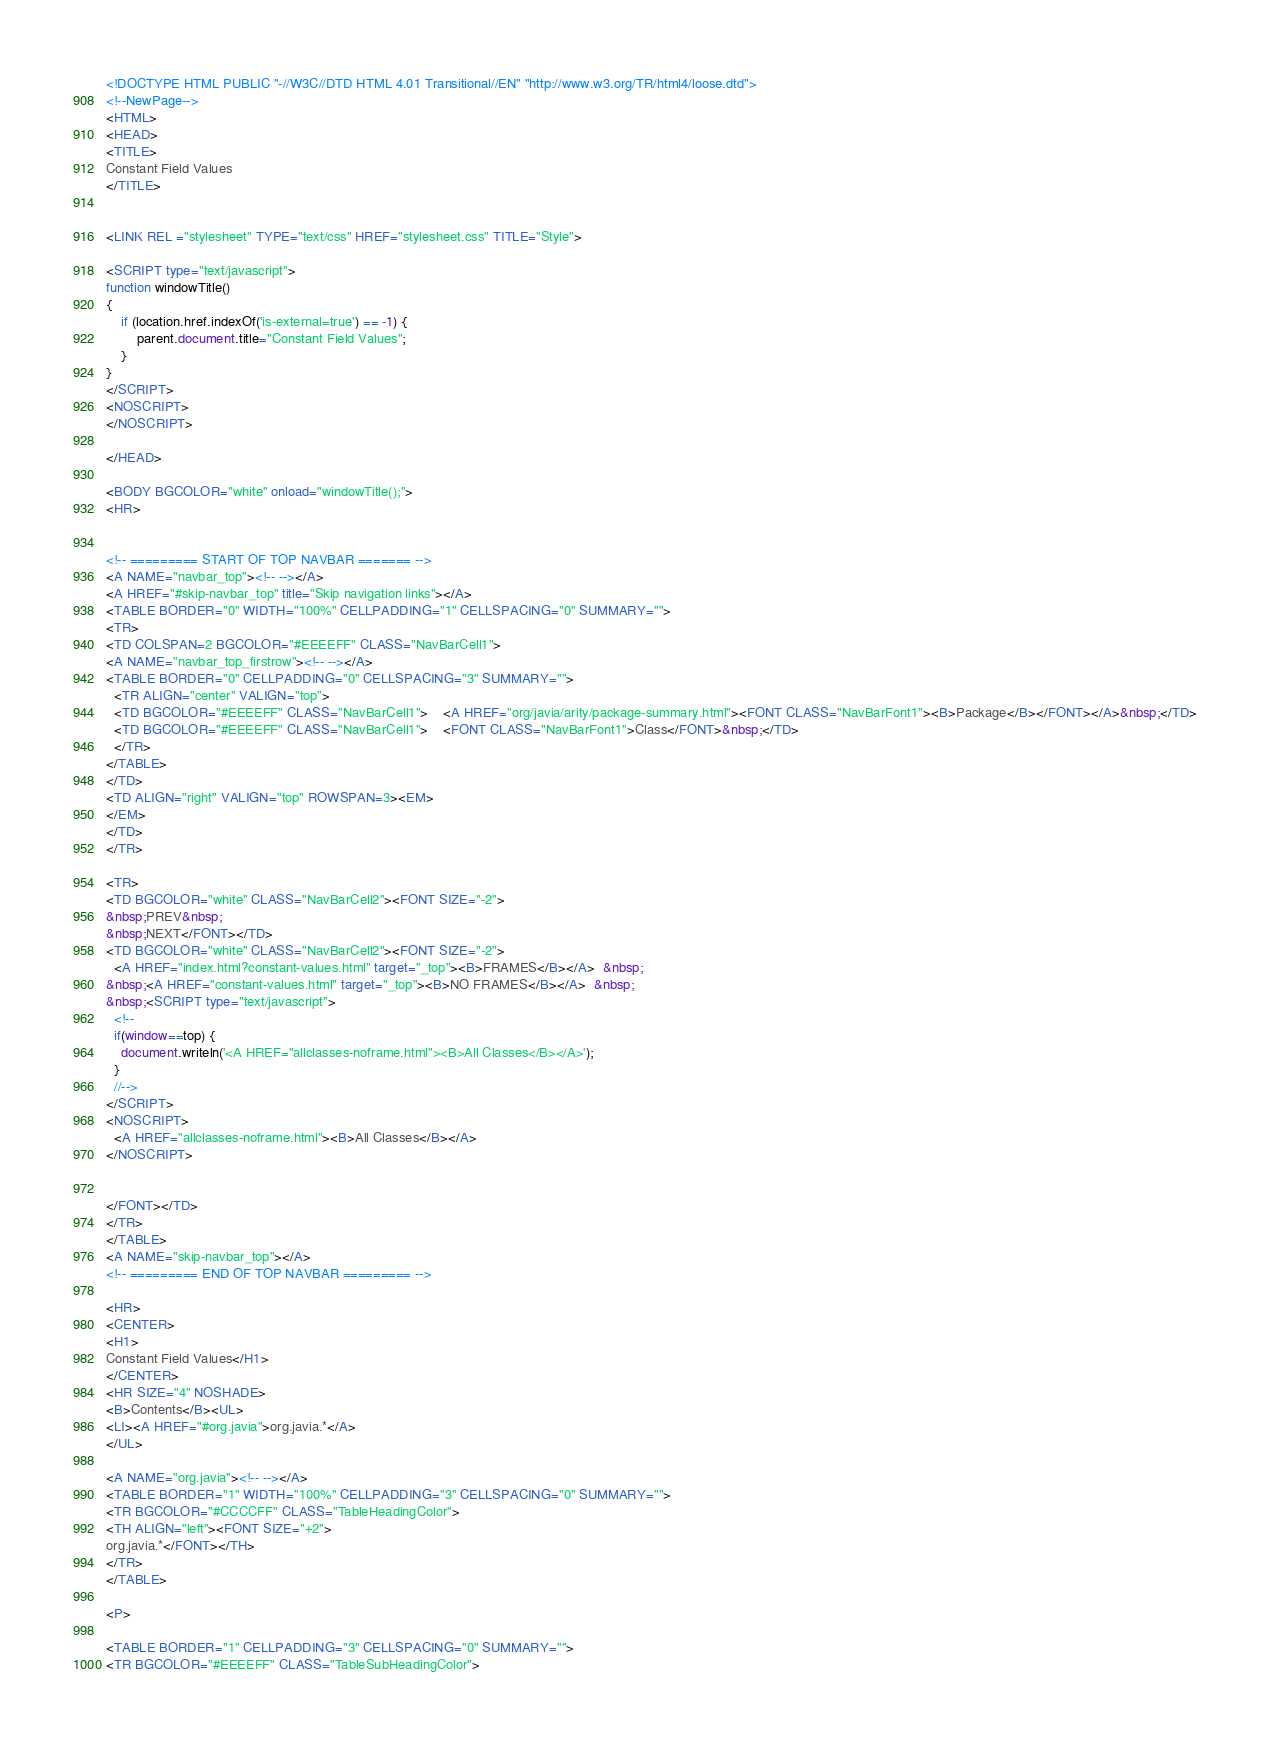Convert code to text. <code><loc_0><loc_0><loc_500><loc_500><_HTML_><!DOCTYPE HTML PUBLIC "-//W3C//DTD HTML 4.01 Transitional//EN" "http://www.w3.org/TR/html4/loose.dtd">
<!--NewPage-->
<HTML>
<HEAD>
<TITLE>
Constant Field Values
</TITLE>


<LINK REL ="stylesheet" TYPE="text/css" HREF="stylesheet.css" TITLE="Style">

<SCRIPT type="text/javascript">
function windowTitle()
{
    if (location.href.indexOf('is-external=true') == -1) {
        parent.document.title="Constant Field Values";
    }
}
</SCRIPT>
<NOSCRIPT>
</NOSCRIPT>

</HEAD>

<BODY BGCOLOR="white" onload="windowTitle();">
<HR>


<!-- ========= START OF TOP NAVBAR ======= -->
<A NAME="navbar_top"><!-- --></A>
<A HREF="#skip-navbar_top" title="Skip navigation links"></A>
<TABLE BORDER="0" WIDTH="100%" CELLPADDING="1" CELLSPACING="0" SUMMARY="">
<TR>
<TD COLSPAN=2 BGCOLOR="#EEEEFF" CLASS="NavBarCell1">
<A NAME="navbar_top_firstrow"><!-- --></A>
<TABLE BORDER="0" CELLPADDING="0" CELLSPACING="3" SUMMARY="">
  <TR ALIGN="center" VALIGN="top">
  <TD BGCOLOR="#EEEEFF" CLASS="NavBarCell1">    <A HREF="org/javia/arity/package-summary.html"><FONT CLASS="NavBarFont1"><B>Package</B></FONT></A>&nbsp;</TD>
  <TD BGCOLOR="#EEEEFF" CLASS="NavBarCell1">    <FONT CLASS="NavBarFont1">Class</FONT>&nbsp;</TD>
  </TR>
</TABLE>
</TD>
<TD ALIGN="right" VALIGN="top" ROWSPAN=3><EM>
</EM>
</TD>
</TR>

<TR>
<TD BGCOLOR="white" CLASS="NavBarCell2"><FONT SIZE="-2">
&nbsp;PREV&nbsp;
&nbsp;NEXT</FONT></TD>
<TD BGCOLOR="white" CLASS="NavBarCell2"><FONT SIZE="-2">
  <A HREF="index.html?constant-values.html" target="_top"><B>FRAMES</B></A>  &nbsp;
&nbsp;<A HREF="constant-values.html" target="_top"><B>NO FRAMES</B></A>  &nbsp;
&nbsp;<SCRIPT type="text/javascript">
  <!--
  if(window==top) {
    document.writeln('<A HREF="allclasses-noframe.html"><B>All Classes</B></A>');
  }
  //-->
</SCRIPT>
<NOSCRIPT>
  <A HREF="allclasses-noframe.html"><B>All Classes</B></A>
</NOSCRIPT>


</FONT></TD>
</TR>
</TABLE>
<A NAME="skip-navbar_top"></A>
<!-- ========= END OF TOP NAVBAR ========= -->

<HR>
<CENTER>
<H1>
Constant Field Values</H1>
</CENTER>
<HR SIZE="4" NOSHADE>
<B>Contents</B><UL>
<LI><A HREF="#org.javia">org.javia.*</A>
</UL>

<A NAME="org.javia"><!-- --></A>
<TABLE BORDER="1" WIDTH="100%" CELLPADDING="3" CELLSPACING="0" SUMMARY="">
<TR BGCOLOR="#CCCCFF" CLASS="TableHeadingColor">
<TH ALIGN="left"><FONT SIZE="+2">
org.javia.*</FONT></TH>
</TR>
</TABLE>

<P>

<TABLE BORDER="1" CELLPADDING="3" CELLSPACING="0" SUMMARY="">
<TR BGCOLOR="#EEEEFF" CLASS="TableSubHeadingColor"></code> 